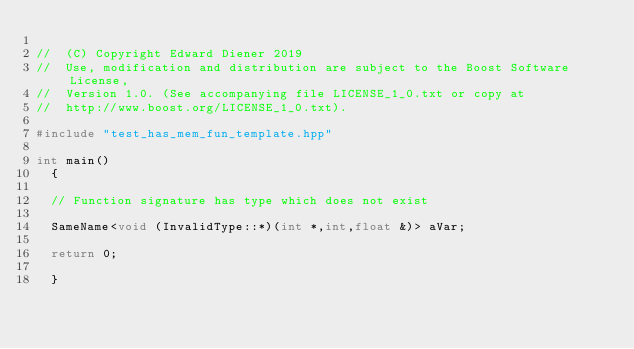<code> <loc_0><loc_0><loc_500><loc_500><_C++_>
//  (C) Copyright Edward Diener 2019
//  Use, modification and distribution are subject to the Boost Software License,
//  Version 1.0. (See accompanying file LICENSE_1_0.txt or copy at
//  http://www.boost.org/LICENSE_1_0.txt).

#include "test_has_mem_fun_template.hpp"

int main()
  {
  
  // Function signature has type which does not exist
  
  SameName<void (InvalidType::*)(int *,int,float &)> aVar;
  
  return 0;

  }
</code> 